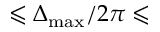Convert formula to latex. <formula><loc_0><loc_0><loc_500><loc_500>\leqslant \Delta _ { \max } / 2 \pi \leqslant</formula> 